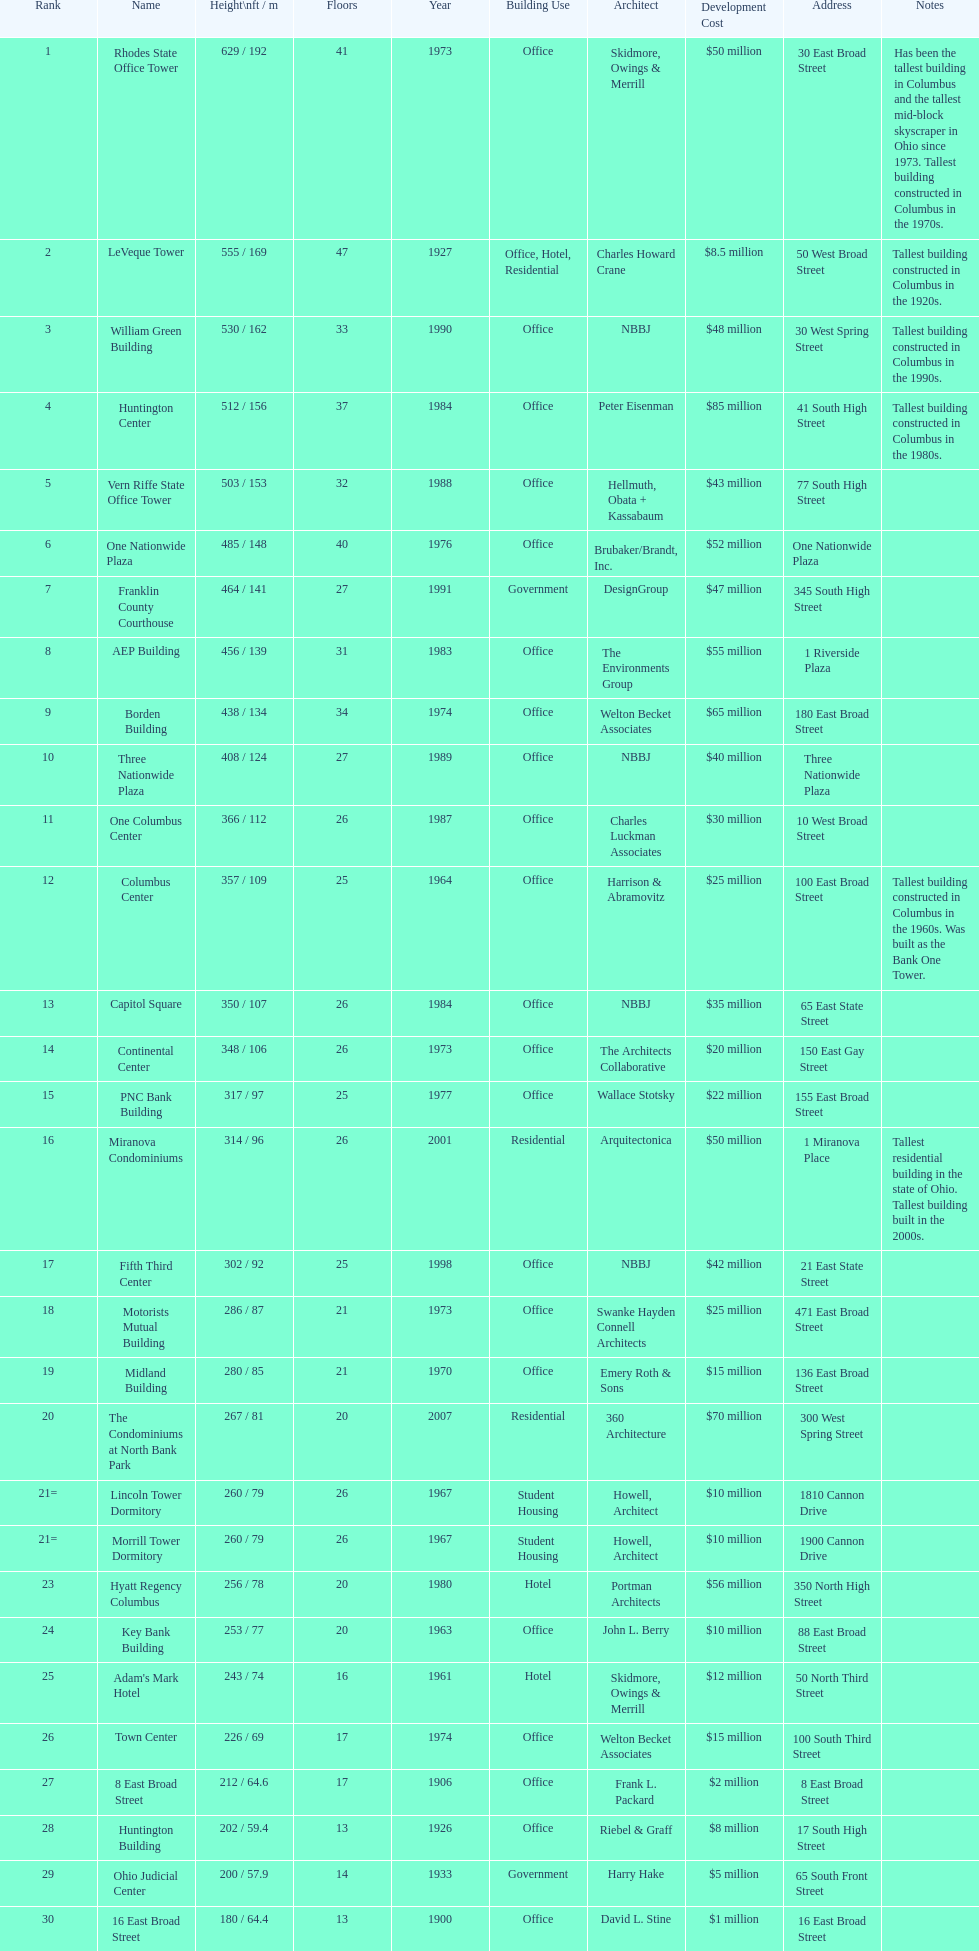What is the tallest building in columbus? Rhodes State Office Tower. 